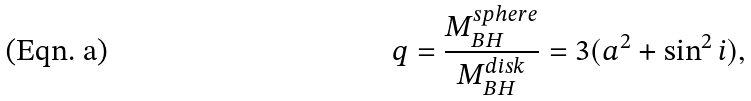Convert formula to latex. <formula><loc_0><loc_0><loc_500><loc_500>q = \frac { M _ { B H } ^ { s p h e r e } } { M _ { B H } ^ { d i s k } } = 3 ( a ^ { 2 } + \sin ^ { 2 } i ) ,</formula> 